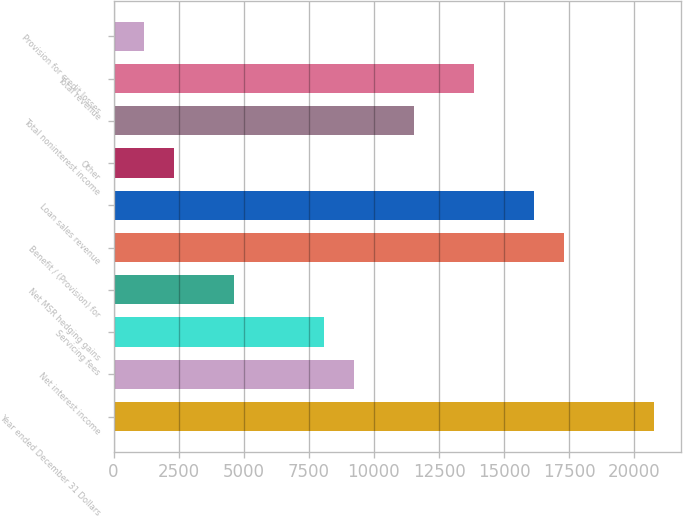Convert chart to OTSL. <chart><loc_0><loc_0><loc_500><loc_500><bar_chart><fcel>Year ended December 31 Dollars<fcel>Net interest income<fcel>Servicing fees<fcel>Net MSR hedging gains<fcel>Benefit / (Provision) for<fcel>Loan sales revenue<fcel>Other<fcel>Total noninterest income<fcel>Total revenue<fcel>Provision for credit losses<nl><fcel>20750<fcel>9223.71<fcel>8071.08<fcel>4613.19<fcel>17292.1<fcel>16139.5<fcel>2307.93<fcel>11529<fcel>13834.2<fcel>1155.3<nl></chart> 